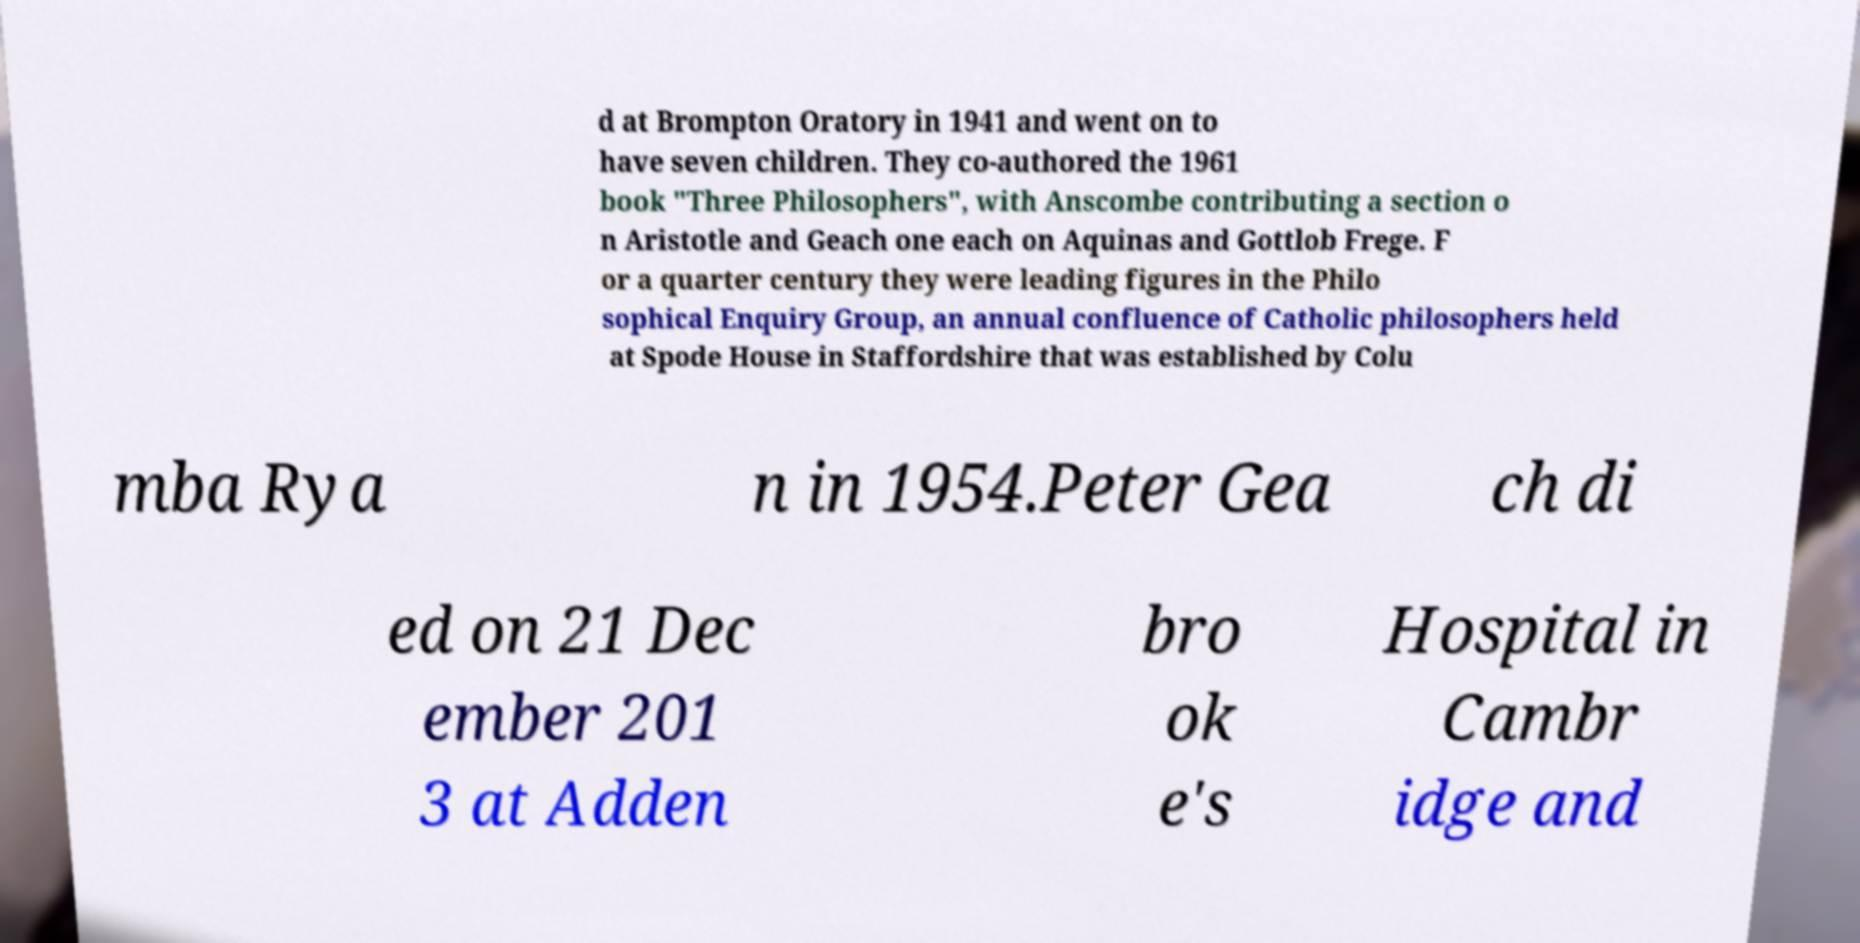What messages or text are displayed in this image? I need them in a readable, typed format. d at Brompton Oratory in 1941 and went on to have seven children. They co-authored the 1961 book "Three Philosophers", with Anscombe contributing a section o n Aristotle and Geach one each on Aquinas and Gottlob Frege. F or a quarter century they were leading figures in the Philo sophical Enquiry Group, an annual confluence of Catholic philosophers held at Spode House in Staffordshire that was established by Colu mba Rya n in 1954.Peter Gea ch di ed on 21 Dec ember 201 3 at Adden bro ok e's Hospital in Cambr idge and 